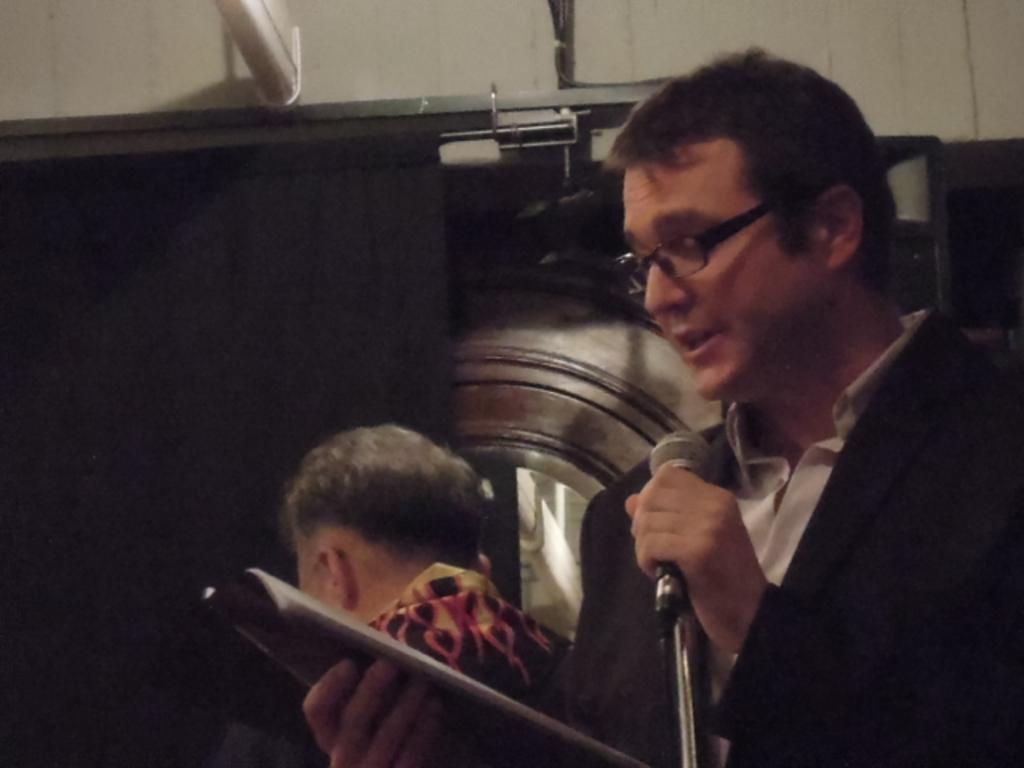What is the person in the image doing? The person in the image is speaking. What can be seen near the person speaking? The person is speaking in front of a microphone. What object is the person holding? The person is holding a book. Who else is present in the image? There is another man standing beside the person speaking. What type of bottle is visible on the wheel in the image? There is no bottle or wheel present in the image. 